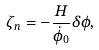<formula> <loc_0><loc_0><loc_500><loc_500>\zeta _ { n } = - \frac { H } { \dot { \phi } _ { 0 } } \delta \phi ,</formula> 